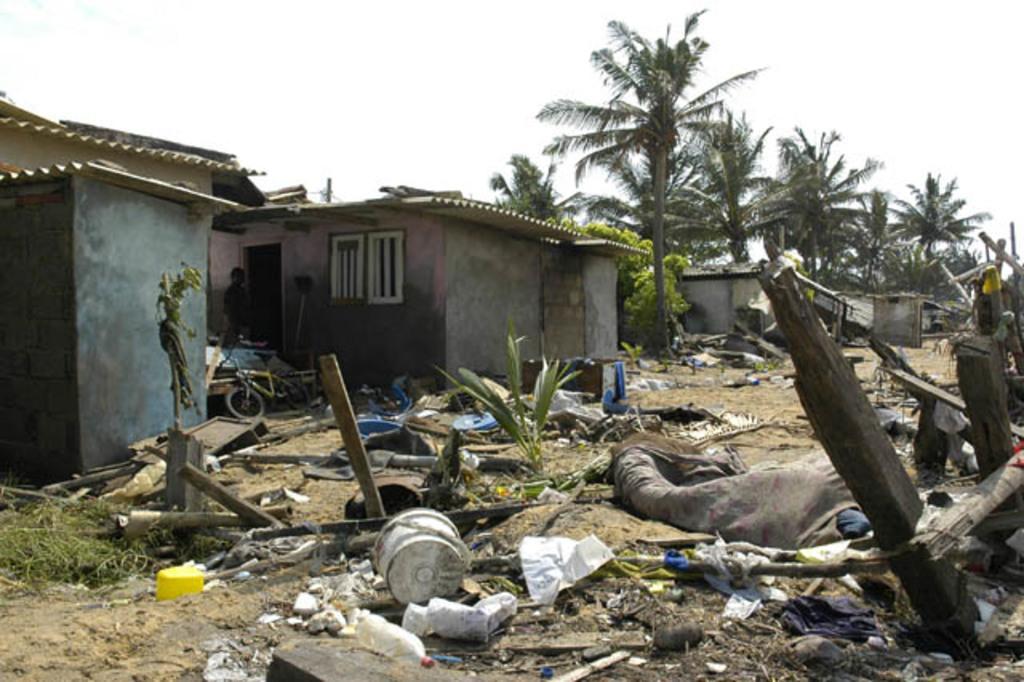Please provide a concise description of this image. In this image, we can see trees, sheds, plants, logs, clothes, a person and we can see a bicycle and some other objects on the ground. At the top, there is sky. 